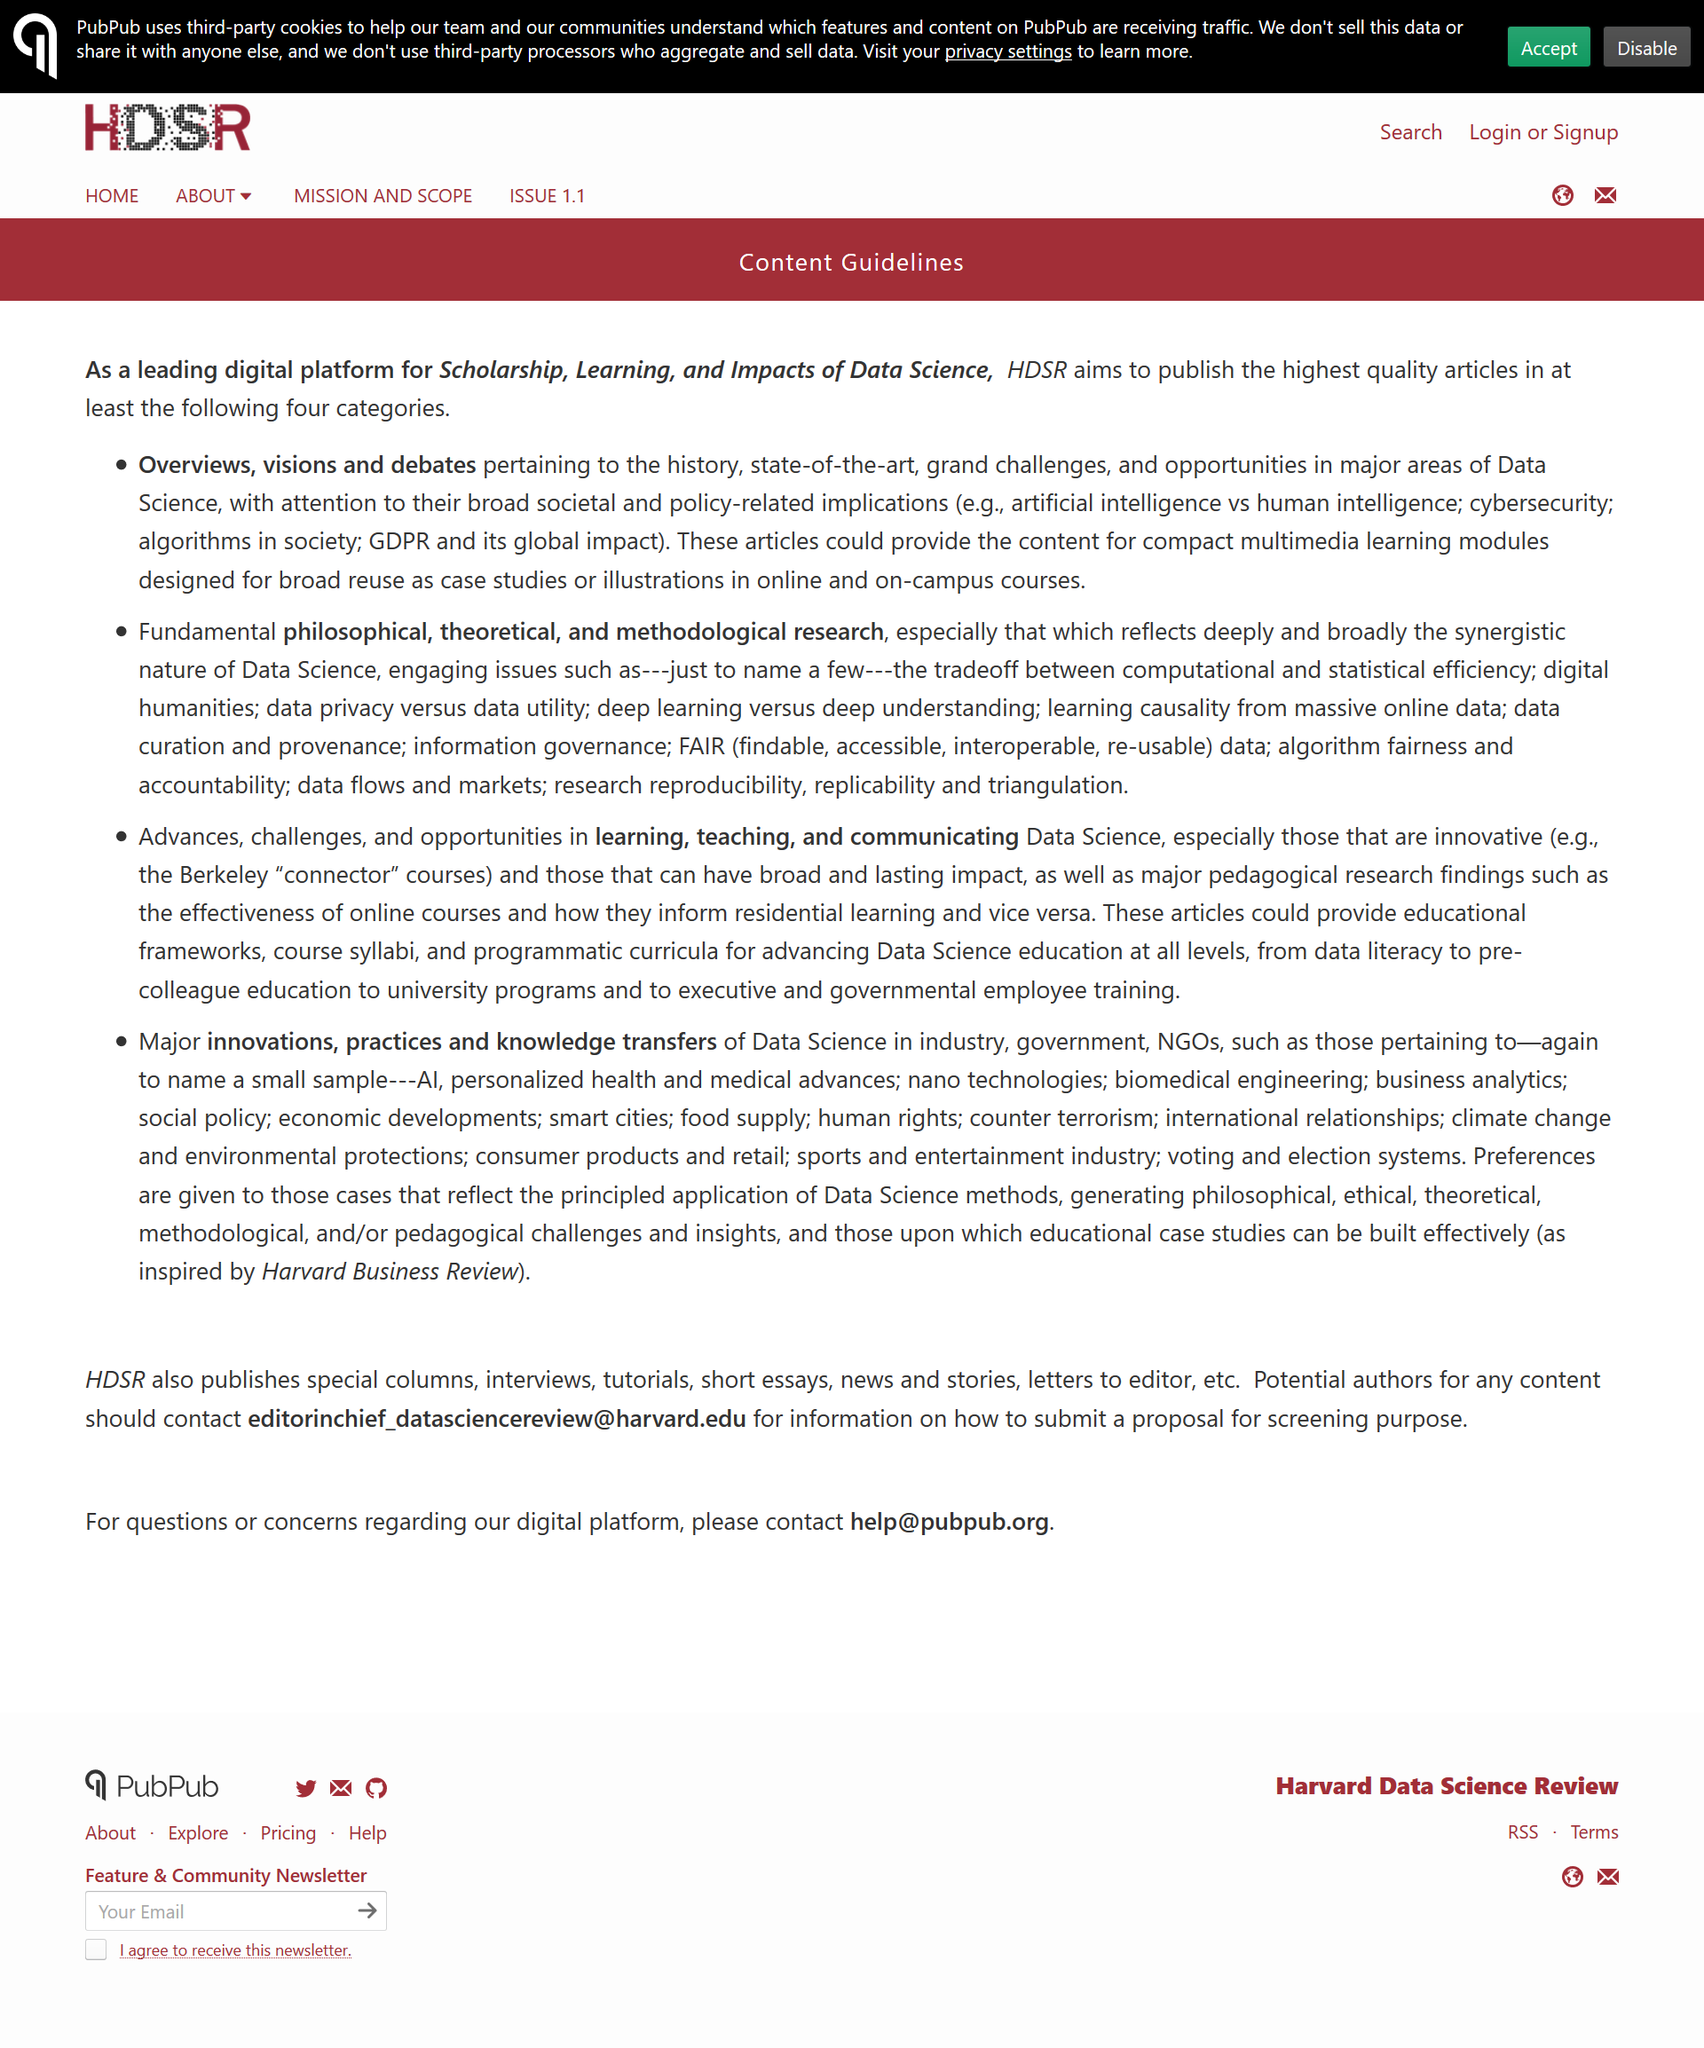Point out several critical features in this image. There are a total of 4 bulletpoints present. This page is a set of guidelines for the content of this page. The topic of the first bulletpoint is overviews. 